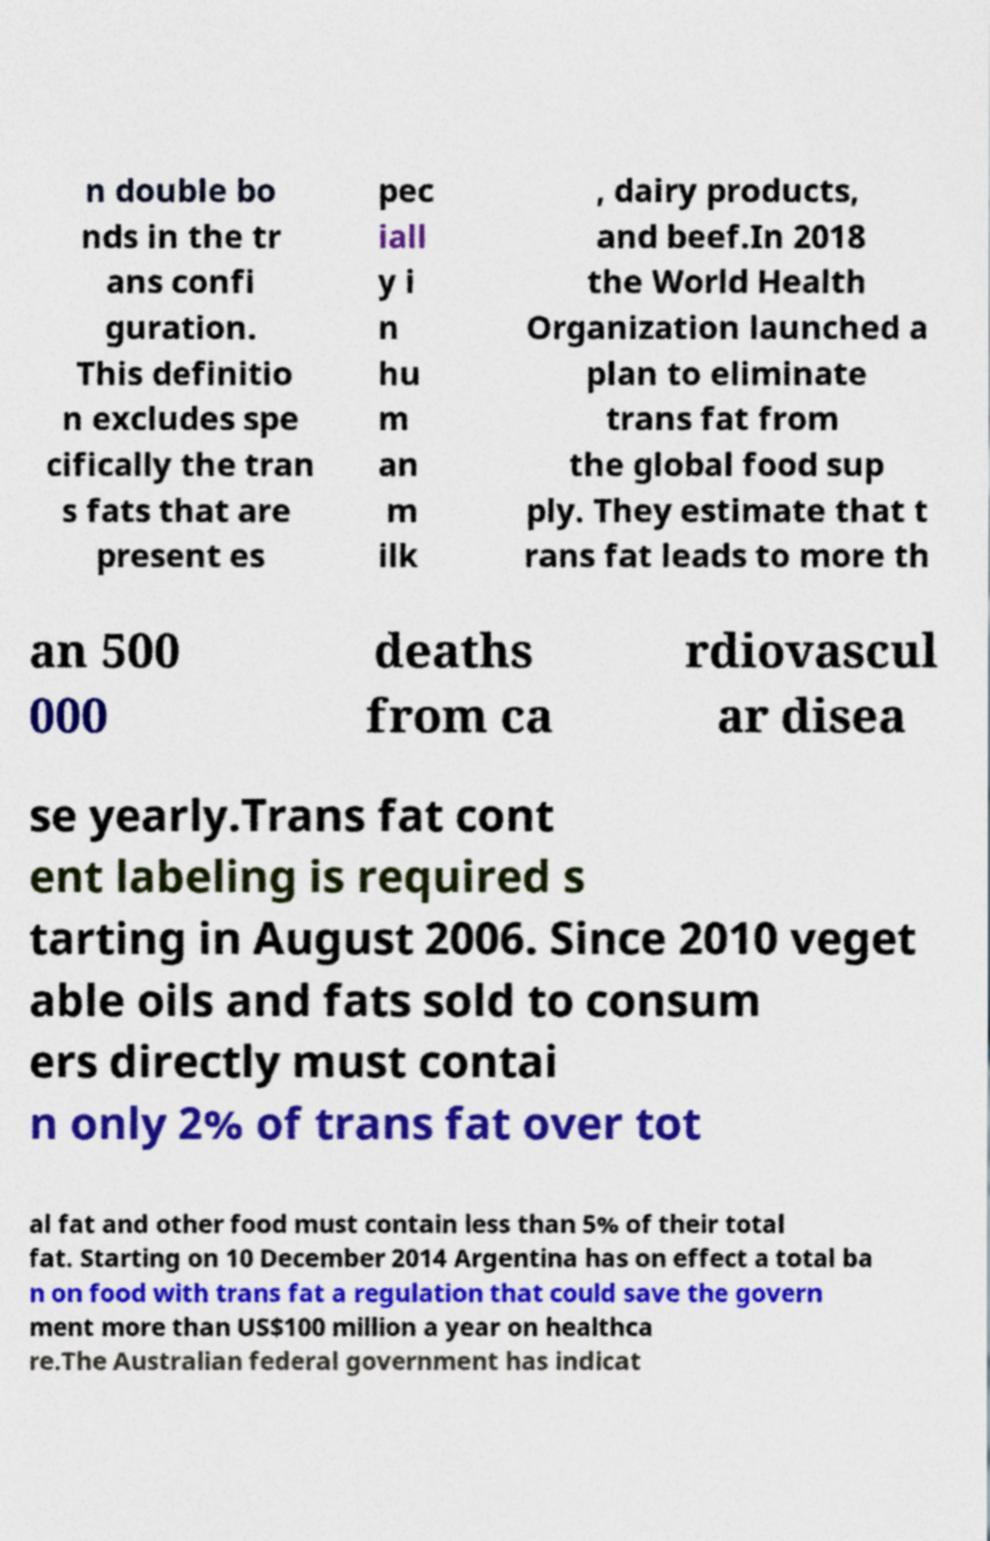Could you extract and type out the text from this image? n double bo nds in the tr ans confi guration. This definitio n excludes spe cifically the tran s fats that are present es pec iall y i n hu m an m ilk , dairy products, and beef.In 2018 the World Health Organization launched a plan to eliminate trans fat from the global food sup ply. They estimate that t rans fat leads to more th an 500 000 deaths from ca rdiovascul ar disea se yearly.Trans fat cont ent labeling is required s tarting in August 2006. Since 2010 veget able oils and fats sold to consum ers directly must contai n only 2% of trans fat over tot al fat and other food must contain less than 5% of their total fat. Starting on 10 December 2014 Argentina has on effect a total ba n on food with trans fat a regulation that could save the govern ment more than US$100 million a year on healthca re.The Australian federal government has indicat 